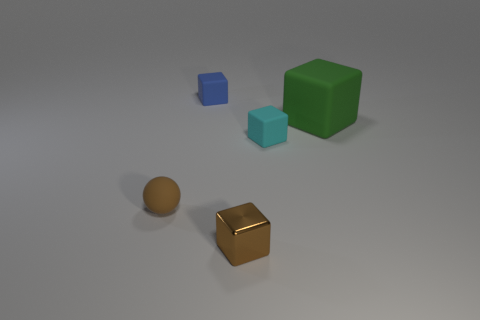Subtract all small cubes. How many cubes are left? 1 Subtract 1 cubes. How many cubes are left? 3 Add 3 tiny matte cubes. How many objects exist? 8 Subtract all green cubes. How many cubes are left? 3 Subtract all purple blocks. Subtract all brown balls. How many blocks are left? 4 Add 1 big rubber things. How many big rubber things are left? 2 Add 3 large green rubber spheres. How many large green rubber spheres exist? 3 Subtract 0 gray blocks. How many objects are left? 5 Subtract all cubes. How many objects are left? 1 Subtract all green rubber things. Subtract all cyan matte things. How many objects are left? 3 